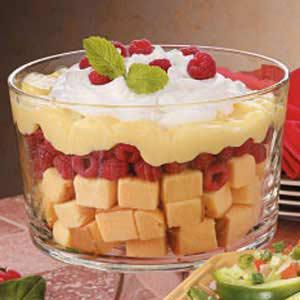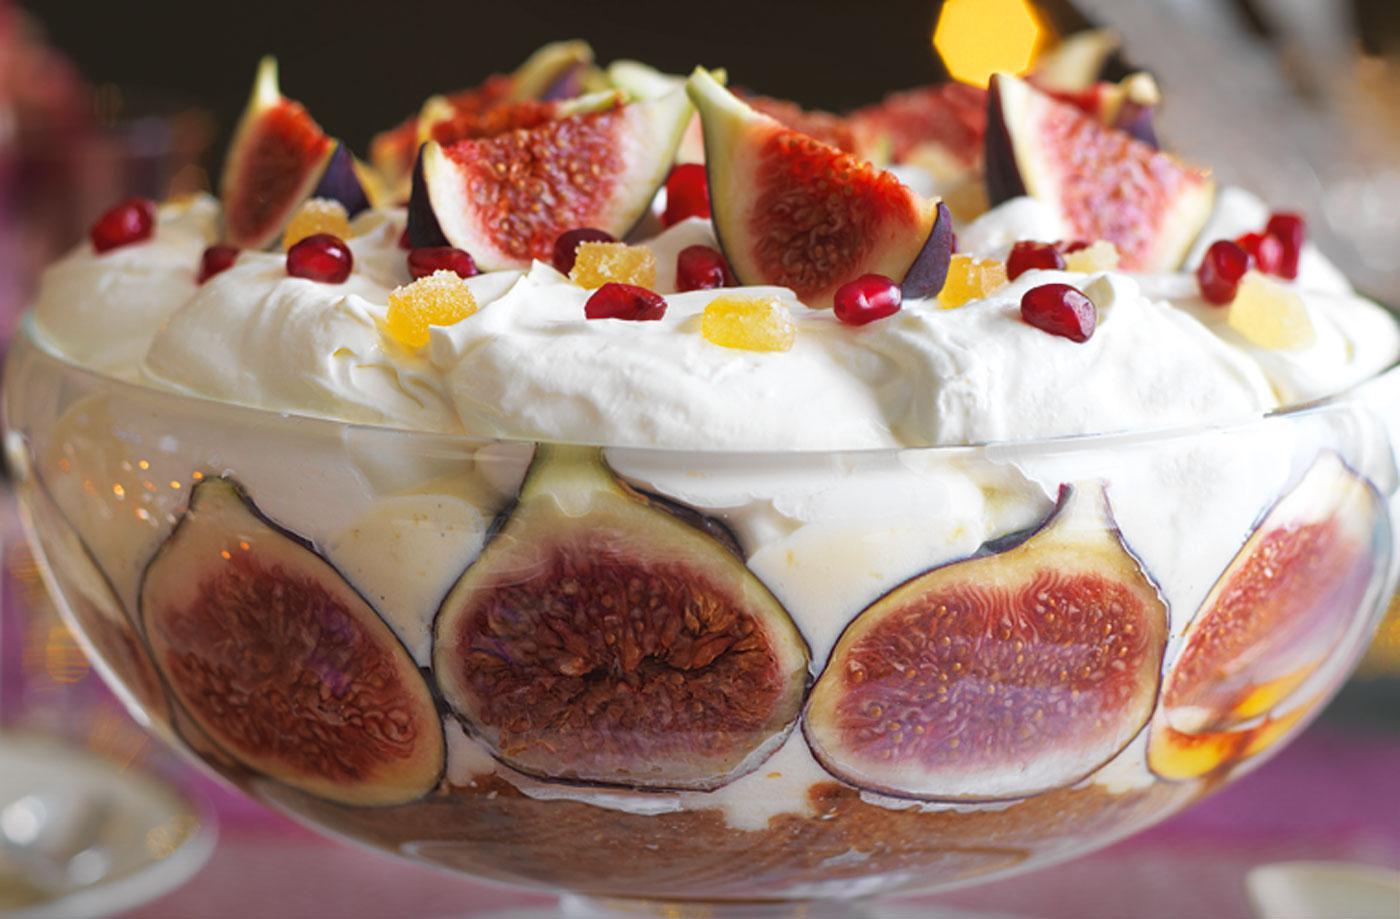The first image is the image on the left, the second image is the image on the right. Given the left and right images, does the statement "At least one image shows a dessert garnished only with strawberry slices." hold true? Answer yes or no. No. 